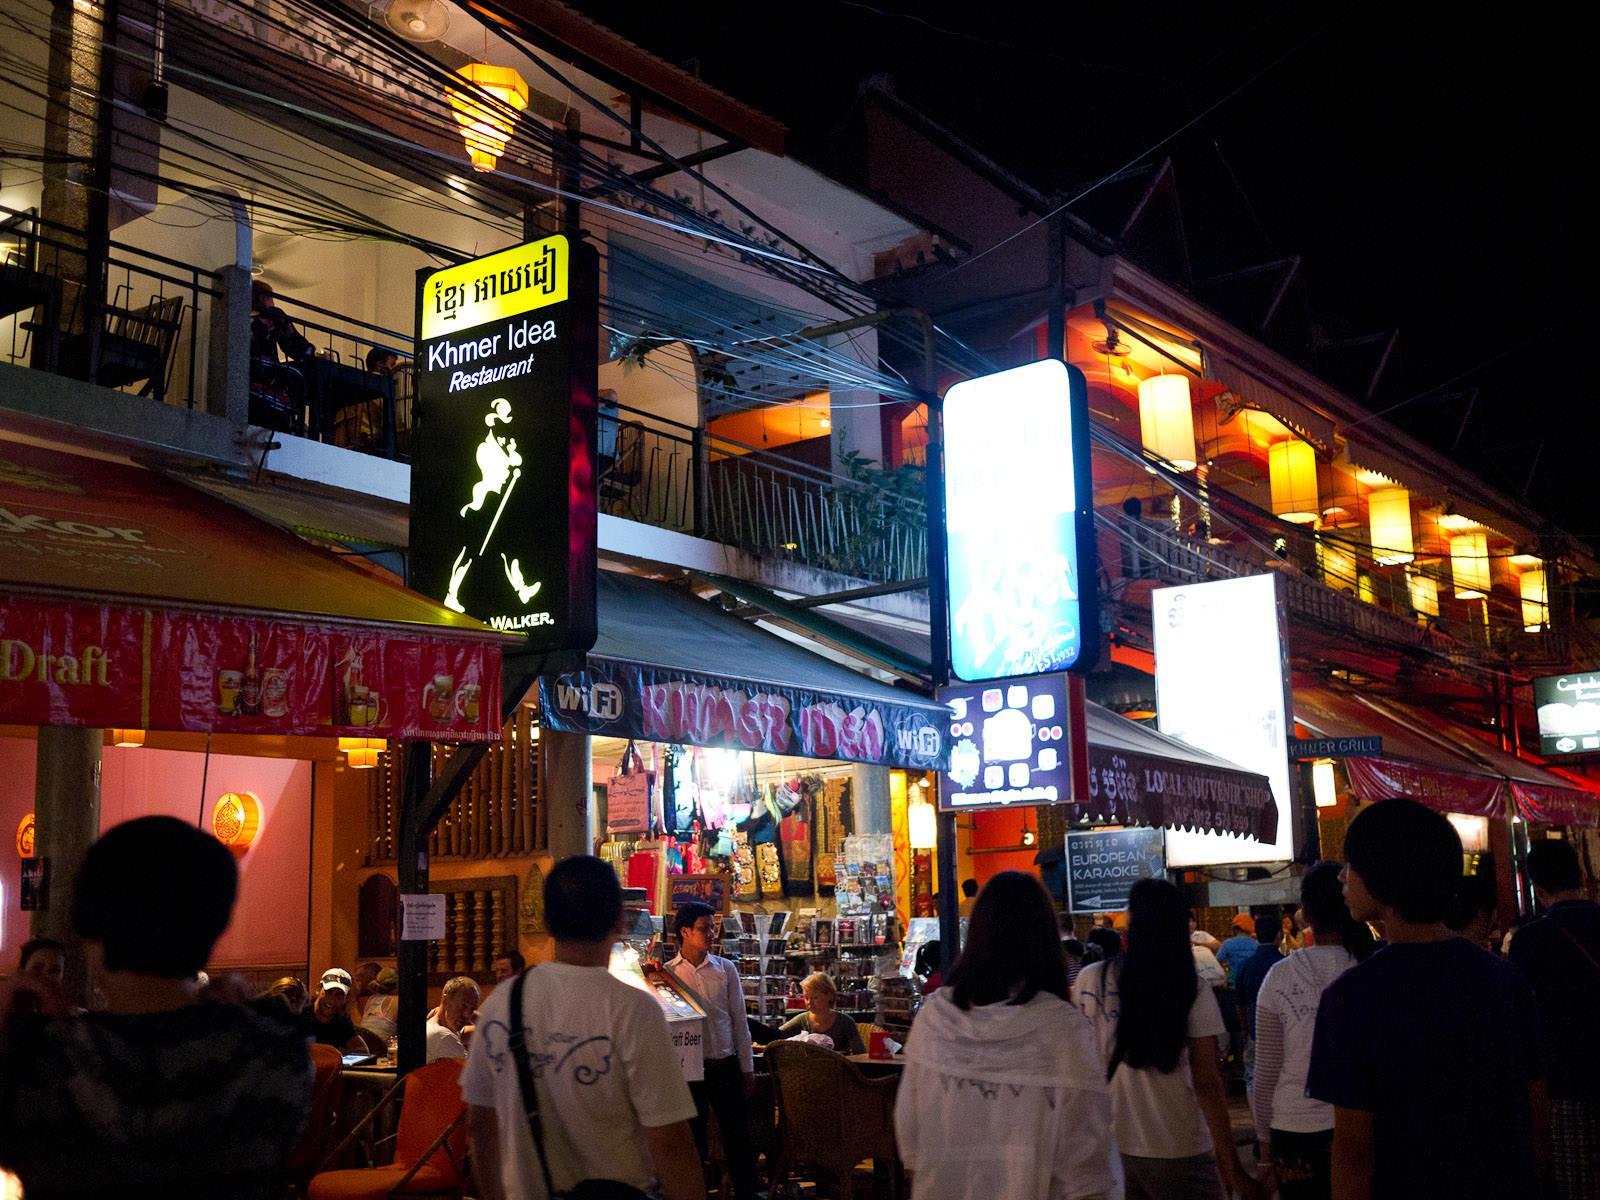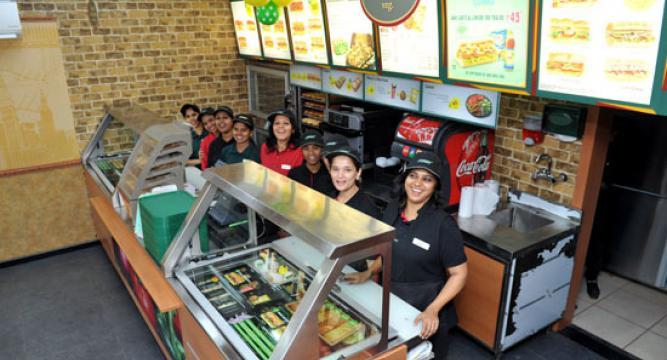The first image is the image on the left, the second image is the image on the right. Evaluate the accuracy of this statement regarding the images: "An image shows crowds on a street with a sign depicting a walking man on the left and a row of cylindrical lights under an overhanding roof on the right.". Is it true? Answer yes or no. Yes. The first image is the image on the left, the second image is the image on the right. Given the left and right images, does the statement "One of these shops has a visible coke machine in it." hold true? Answer yes or no. Yes. 